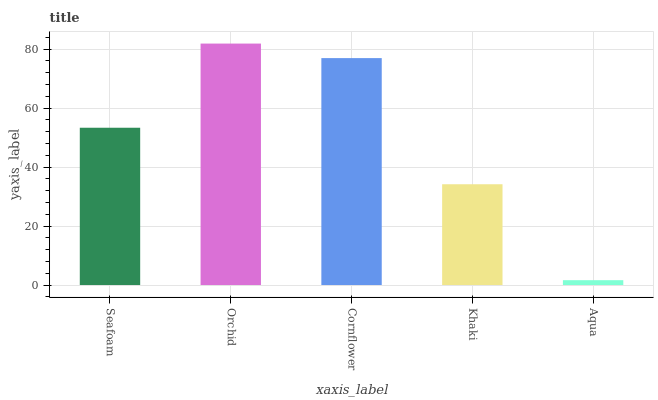Is Aqua the minimum?
Answer yes or no. Yes. Is Orchid the maximum?
Answer yes or no. Yes. Is Cornflower the minimum?
Answer yes or no. No. Is Cornflower the maximum?
Answer yes or no. No. Is Orchid greater than Cornflower?
Answer yes or no. Yes. Is Cornflower less than Orchid?
Answer yes or no. Yes. Is Cornflower greater than Orchid?
Answer yes or no. No. Is Orchid less than Cornflower?
Answer yes or no. No. Is Seafoam the high median?
Answer yes or no. Yes. Is Seafoam the low median?
Answer yes or no. Yes. Is Aqua the high median?
Answer yes or no. No. Is Aqua the low median?
Answer yes or no. No. 